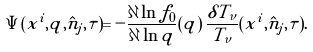Convert formula to latex. <formula><loc_0><loc_0><loc_500><loc_500>\Psi ( x ^ { i } , q , \hat { n } _ { j } , \tau ) = - \frac { \partial \ln f _ { 0 } } { \partial \ln q } ( q ) \, \frac { \delta T _ { \nu } } { T _ { \nu } } ( x ^ { i } , \hat { n } _ { j } , \tau ) .</formula> 